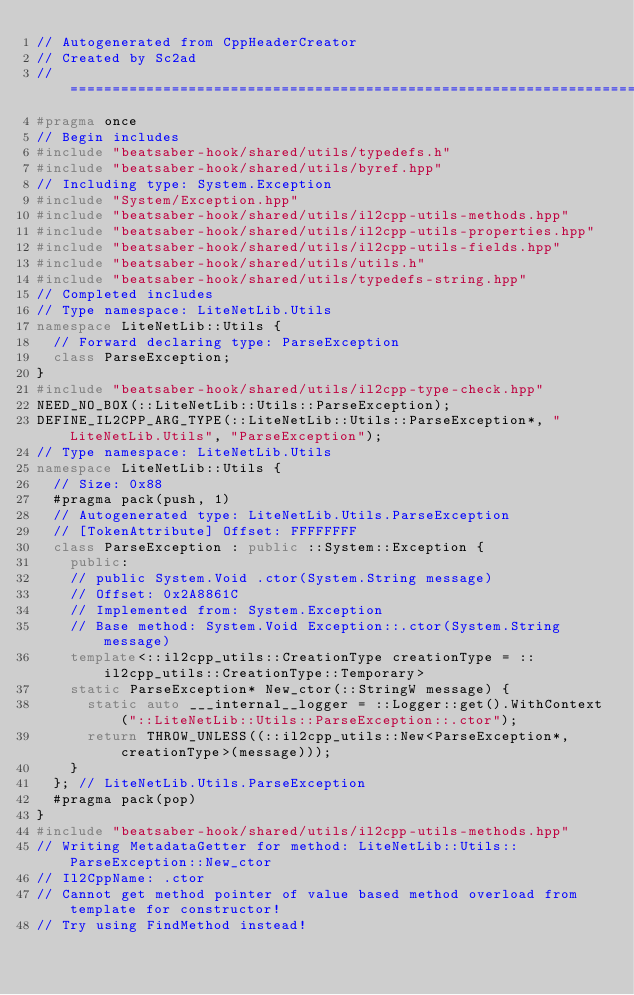<code> <loc_0><loc_0><loc_500><loc_500><_C++_>// Autogenerated from CppHeaderCreator
// Created by Sc2ad
// =========================================================================
#pragma once
// Begin includes
#include "beatsaber-hook/shared/utils/typedefs.h"
#include "beatsaber-hook/shared/utils/byref.hpp"
// Including type: System.Exception
#include "System/Exception.hpp"
#include "beatsaber-hook/shared/utils/il2cpp-utils-methods.hpp"
#include "beatsaber-hook/shared/utils/il2cpp-utils-properties.hpp"
#include "beatsaber-hook/shared/utils/il2cpp-utils-fields.hpp"
#include "beatsaber-hook/shared/utils/utils.h"
#include "beatsaber-hook/shared/utils/typedefs-string.hpp"
// Completed includes
// Type namespace: LiteNetLib.Utils
namespace LiteNetLib::Utils {
  // Forward declaring type: ParseException
  class ParseException;
}
#include "beatsaber-hook/shared/utils/il2cpp-type-check.hpp"
NEED_NO_BOX(::LiteNetLib::Utils::ParseException);
DEFINE_IL2CPP_ARG_TYPE(::LiteNetLib::Utils::ParseException*, "LiteNetLib.Utils", "ParseException");
// Type namespace: LiteNetLib.Utils
namespace LiteNetLib::Utils {
  // Size: 0x88
  #pragma pack(push, 1)
  // Autogenerated type: LiteNetLib.Utils.ParseException
  // [TokenAttribute] Offset: FFFFFFFF
  class ParseException : public ::System::Exception {
    public:
    // public System.Void .ctor(System.String message)
    // Offset: 0x2A8861C
    // Implemented from: System.Exception
    // Base method: System.Void Exception::.ctor(System.String message)
    template<::il2cpp_utils::CreationType creationType = ::il2cpp_utils::CreationType::Temporary>
    static ParseException* New_ctor(::StringW message) {
      static auto ___internal__logger = ::Logger::get().WithContext("::LiteNetLib::Utils::ParseException::.ctor");
      return THROW_UNLESS((::il2cpp_utils::New<ParseException*, creationType>(message)));
    }
  }; // LiteNetLib.Utils.ParseException
  #pragma pack(pop)
}
#include "beatsaber-hook/shared/utils/il2cpp-utils-methods.hpp"
// Writing MetadataGetter for method: LiteNetLib::Utils::ParseException::New_ctor
// Il2CppName: .ctor
// Cannot get method pointer of value based method overload from template for constructor!
// Try using FindMethod instead!
</code> 